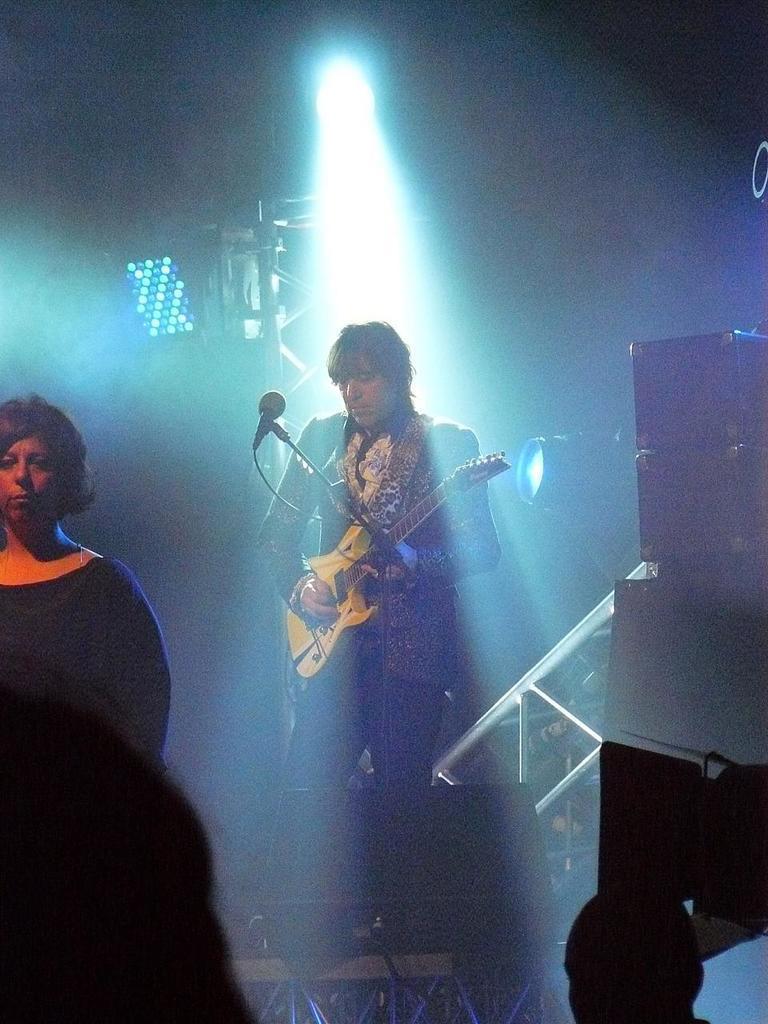In one or two sentences, can you explain what this image depicts? As we can see in the image, there is a light and two people over here. The man who is standing here is holding guitar in his hand and in front of him there is a mic. 